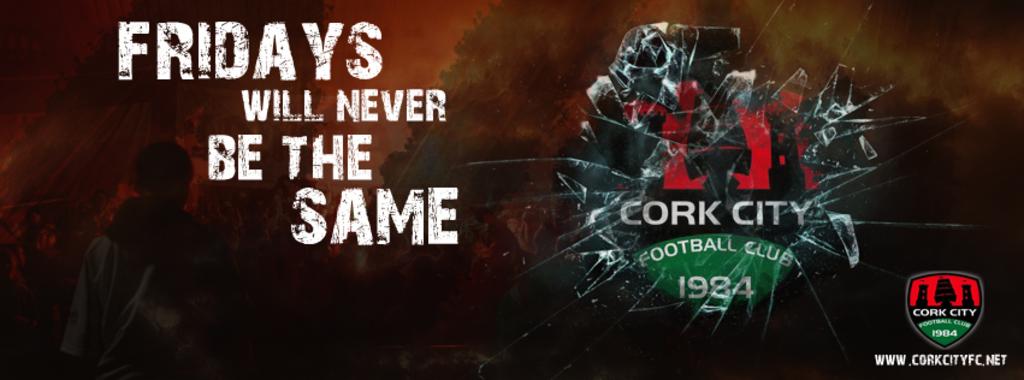What is the slogan in white?
Keep it short and to the point. Fridays will never be the same. 